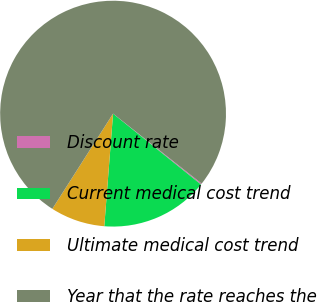<chart> <loc_0><loc_0><loc_500><loc_500><pie_chart><fcel>Discount rate<fcel>Current medical cost trend<fcel>Ultimate medical cost trend<fcel>Year that the rate reaches the<nl><fcel>0.16%<fcel>15.44%<fcel>7.8%<fcel>76.6%<nl></chart> 